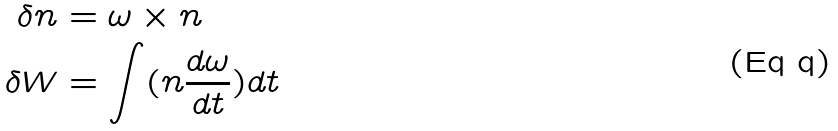Convert formula to latex. <formula><loc_0><loc_0><loc_500><loc_500>\delta n & = \omega \times n \\ \delta W & = \int ( n \frac { d \omega } { d t } ) d t</formula> 